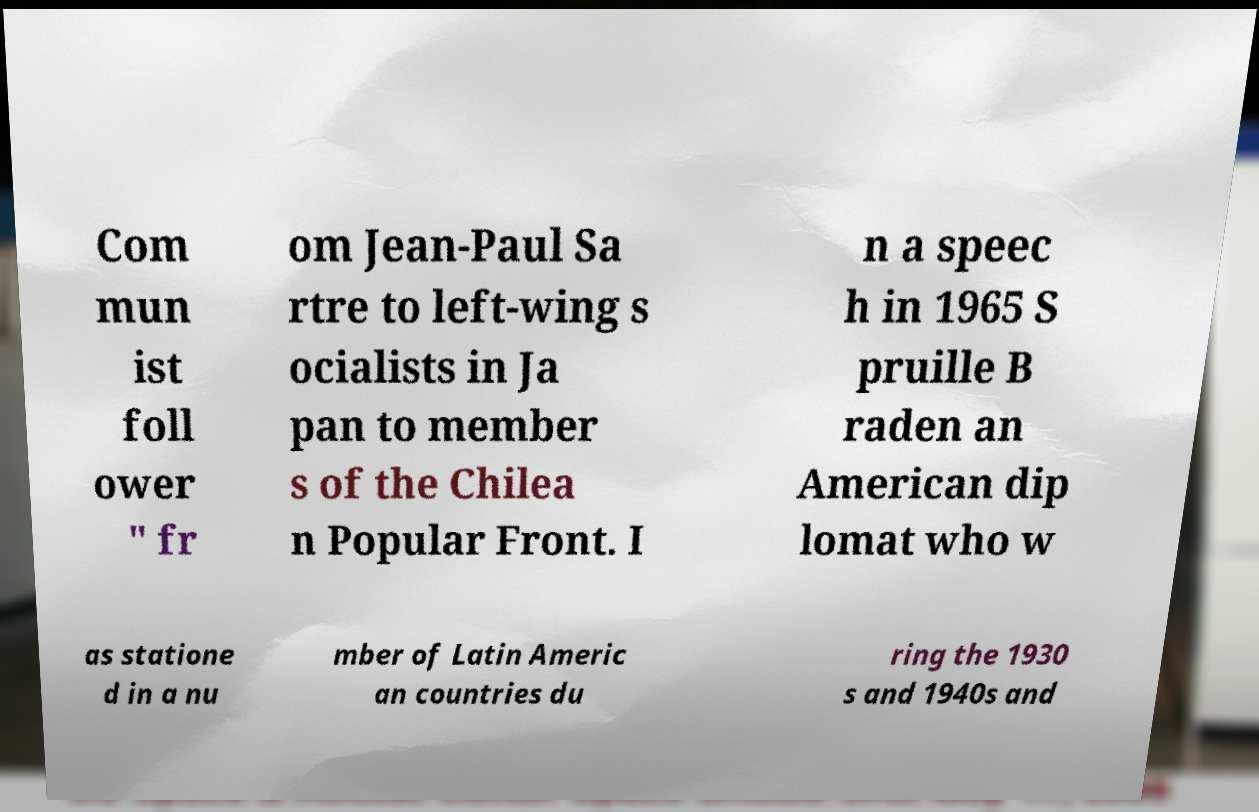Can you read and provide the text displayed in the image?This photo seems to have some interesting text. Can you extract and type it out for me? Com mun ist foll ower " fr om Jean-Paul Sa rtre to left-wing s ocialists in Ja pan to member s of the Chilea n Popular Front. I n a speec h in 1965 S pruille B raden an American dip lomat who w as statione d in a nu mber of Latin Americ an countries du ring the 1930 s and 1940s and 